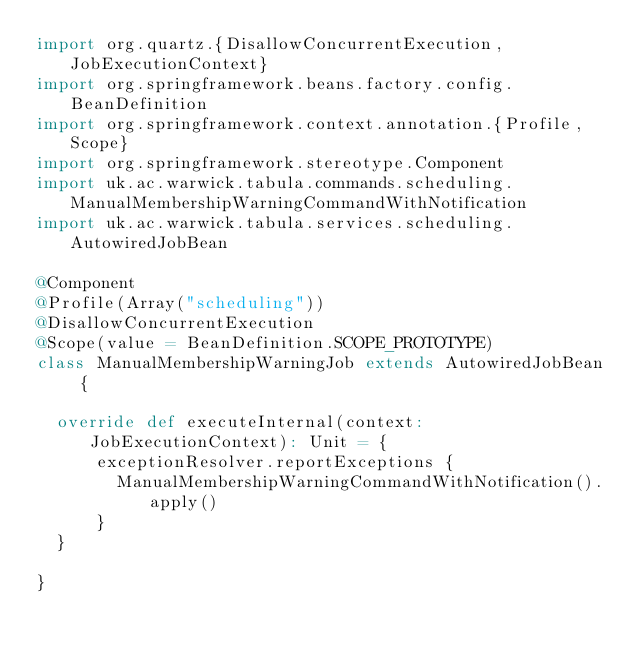<code> <loc_0><loc_0><loc_500><loc_500><_Scala_>import org.quartz.{DisallowConcurrentExecution, JobExecutionContext}
import org.springframework.beans.factory.config.BeanDefinition
import org.springframework.context.annotation.{Profile, Scope}
import org.springframework.stereotype.Component
import uk.ac.warwick.tabula.commands.scheduling.ManualMembershipWarningCommandWithNotification
import uk.ac.warwick.tabula.services.scheduling.AutowiredJobBean

@Component
@Profile(Array("scheduling"))
@DisallowConcurrentExecution
@Scope(value = BeanDefinition.SCOPE_PROTOTYPE)
class ManualMembershipWarningJob extends AutowiredJobBean {

	override def executeInternal(context: JobExecutionContext): Unit = {
			exceptionResolver.reportExceptions {
				ManualMembershipWarningCommandWithNotification().apply()
			}
	}

}</code> 